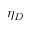<formula> <loc_0><loc_0><loc_500><loc_500>\eta _ { D }</formula> 